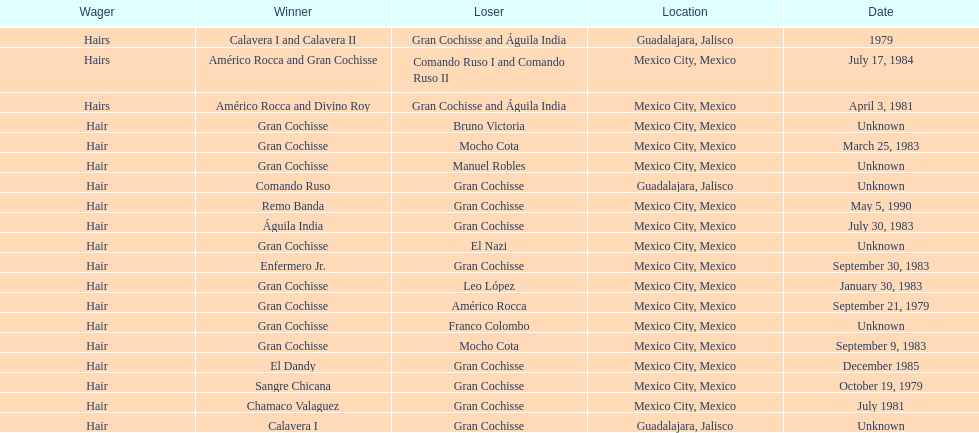When was gran chochisse first match that had a full date on record? September 21, 1979. 